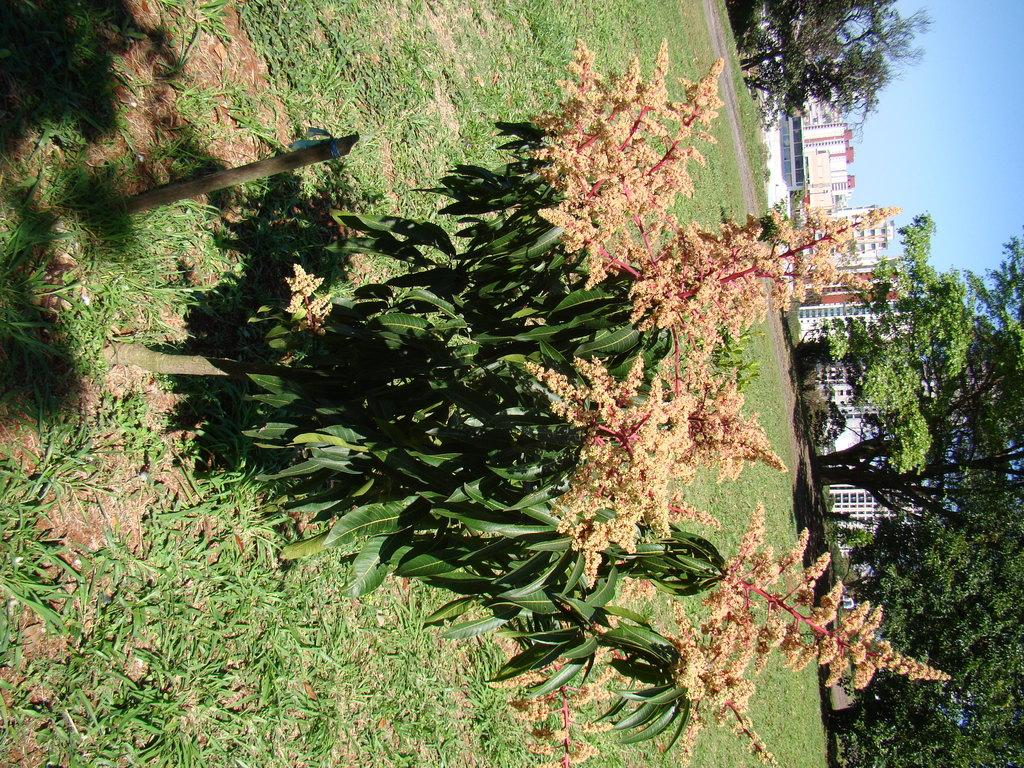What type of vegetation can be seen in the image? There are plants, grass, and trees visible in the image. What type of structures can be seen in the background of the image? There are buildings in the background of the image. What part of the natural environment is visible in the image? The sky is visible in the background of the image. How many jellyfish can be seen swimming in the sky in the image? There are no jellyfish visible in the image, as it features plants, grass, trees, buildings, and the sky. 